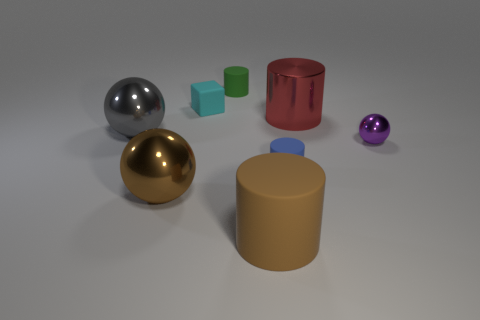Is there any other thing that is the same color as the cube?
Keep it short and to the point. No. There is a thing that is to the right of the metal object that is behind the big gray metal object; what is its shape?
Your answer should be compact. Sphere. Are there more tiny metal objects than tiny purple rubber cylinders?
Offer a very short reply. Yes. How many large objects are on the left side of the cube and to the right of the gray object?
Make the answer very short. 1. What number of big brown cylinders are on the right side of the big cylinder that is right of the blue object?
Your answer should be compact. 0. How many things are balls to the right of the tiny block or brown things left of the tiny cyan cube?
Offer a very short reply. 2. There is another small object that is the same shape as the blue thing; what is it made of?
Provide a succinct answer. Rubber. What number of things are either tiny rubber cylinders that are in front of the tiny purple metallic ball or tiny things?
Ensure brevity in your answer.  4. What shape is the tiny blue object that is the same material as the tiny green thing?
Keep it short and to the point. Cylinder. What number of large brown matte things are the same shape as the red shiny object?
Provide a succinct answer. 1. 